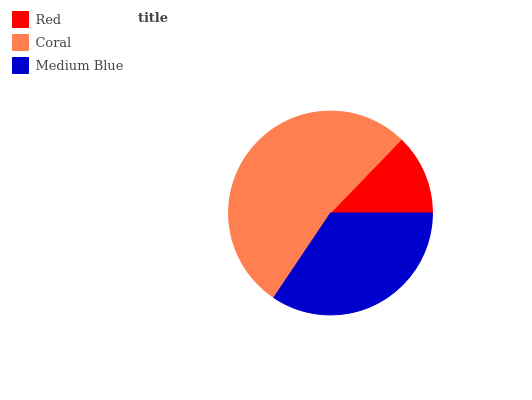Is Red the minimum?
Answer yes or no. Yes. Is Coral the maximum?
Answer yes or no. Yes. Is Medium Blue the minimum?
Answer yes or no. No. Is Medium Blue the maximum?
Answer yes or no. No. Is Coral greater than Medium Blue?
Answer yes or no. Yes. Is Medium Blue less than Coral?
Answer yes or no. Yes. Is Medium Blue greater than Coral?
Answer yes or no. No. Is Coral less than Medium Blue?
Answer yes or no. No. Is Medium Blue the high median?
Answer yes or no. Yes. Is Medium Blue the low median?
Answer yes or no. Yes. Is Coral the high median?
Answer yes or no. No. Is Red the low median?
Answer yes or no. No. 